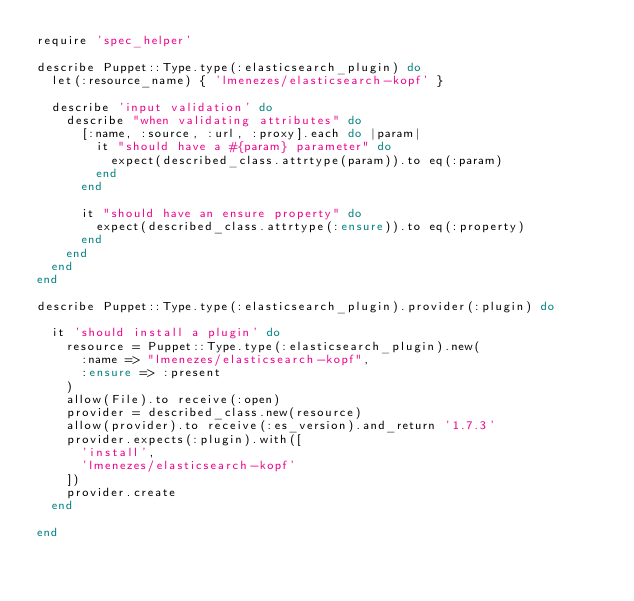<code> <loc_0><loc_0><loc_500><loc_500><_Ruby_>require 'spec_helper'

describe Puppet::Type.type(:elasticsearch_plugin) do
  let(:resource_name) { 'lmenezes/elasticsearch-kopf' }

  describe 'input validation' do
    describe "when validating attributes" do
      [:name, :source, :url, :proxy].each do |param|
        it "should have a #{param} parameter" do
          expect(described_class.attrtype(param)).to eq(:param)
        end
      end

      it "should have an ensure property" do
        expect(described_class.attrtype(:ensure)).to eq(:property)
      end
    end
  end
end

describe Puppet::Type.type(:elasticsearch_plugin).provider(:plugin) do

  it 'should install a plugin' do
    resource = Puppet::Type.type(:elasticsearch_plugin).new(
      :name => "lmenezes/elasticsearch-kopf",
      :ensure => :present
    )
    allow(File).to receive(:open)
    provider = described_class.new(resource)
    allow(provider).to receive(:es_version).and_return '1.7.3'
    provider.expects(:plugin).with([
      'install',
      'lmenezes/elasticsearch-kopf'
    ])
    provider.create
  end

end
</code> 